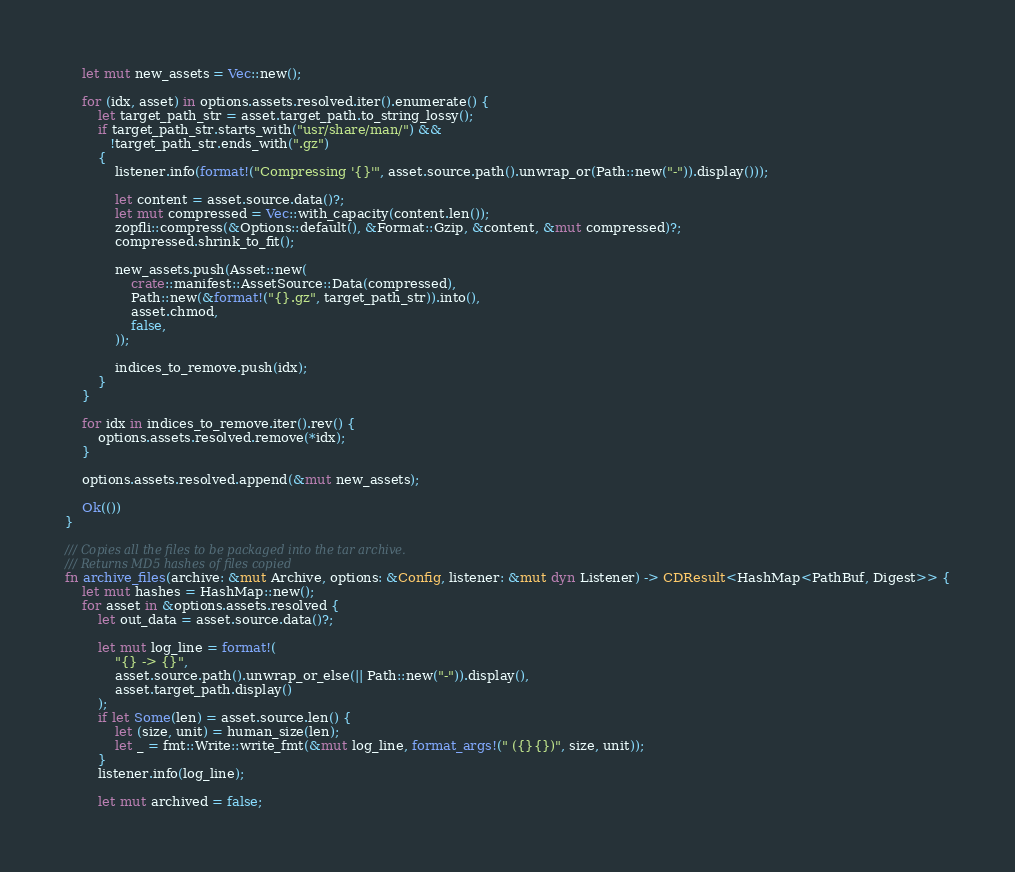<code> <loc_0><loc_0><loc_500><loc_500><_Rust_>    let mut new_assets = Vec::new();

    for (idx, asset) in options.assets.resolved.iter().enumerate() {
        let target_path_str = asset.target_path.to_string_lossy();
        if target_path_str.starts_with("usr/share/man/") &&
           !target_path_str.ends_with(".gz")
        {
            listener.info(format!("Compressing '{}'", asset.source.path().unwrap_or(Path::new("-")).display()));

            let content = asset.source.data()?;
            let mut compressed = Vec::with_capacity(content.len());
            zopfli::compress(&Options::default(), &Format::Gzip, &content, &mut compressed)?;
            compressed.shrink_to_fit();

            new_assets.push(Asset::new(
                crate::manifest::AssetSource::Data(compressed),
                Path::new(&format!("{}.gz", target_path_str)).into(),
                asset.chmod,
                false,
            ));

            indices_to_remove.push(idx);
        }
    }

    for idx in indices_to_remove.iter().rev() {
        options.assets.resolved.remove(*idx);
    }

    options.assets.resolved.append(&mut new_assets);

    Ok(())
}

/// Copies all the files to be packaged into the tar archive.
/// Returns MD5 hashes of files copied
fn archive_files(archive: &mut Archive, options: &Config, listener: &mut dyn Listener) -> CDResult<HashMap<PathBuf, Digest>> {
    let mut hashes = HashMap::new();
    for asset in &options.assets.resolved {
        let out_data = asset.source.data()?;

        let mut log_line = format!(
            "{} -> {}",
            asset.source.path().unwrap_or_else(|| Path::new("-")).display(),
            asset.target_path.display()
        );
        if let Some(len) = asset.source.len() {
            let (size, unit) = human_size(len);
            let _ = fmt::Write::write_fmt(&mut log_line, format_args!(" ({}{})", size, unit));
        }
        listener.info(log_line);

        let mut archived = false;</code> 